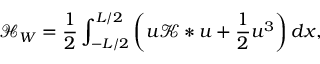Convert formula to latex. <formula><loc_0><loc_0><loc_500><loc_500>\mathcal { H } _ { W } = \frac { 1 } { 2 } \int _ { - L / 2 } ^ { L / 2 } \left ( u \mathcal { K } * u + \frac { 1 } { 2 } u ^ { 3 } \right ) d x ,</formula> 